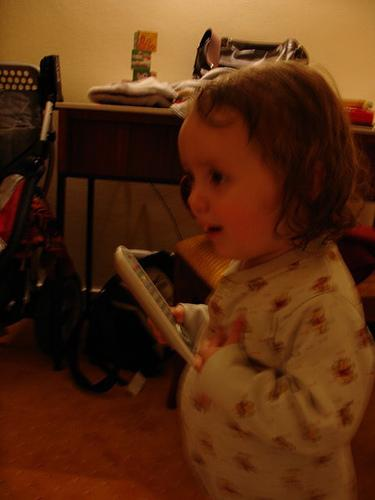Judging by the childs hair what did they just get done with? Please explain your reasoning. bath. The hair looks wet and uncombed. 